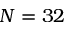Convert formula to latex. <formula><loc_0><loc_0><loc_500><loc_500>N = 3 2</formula> 